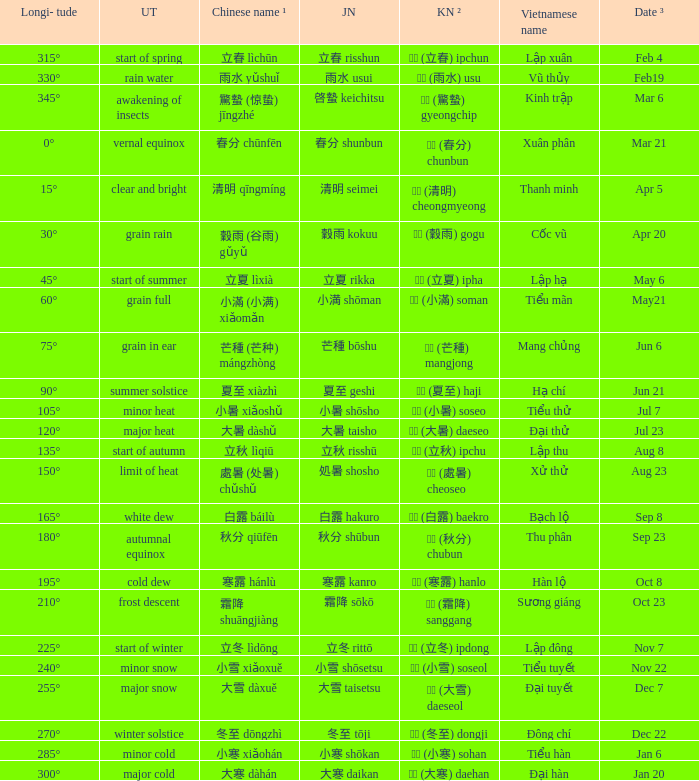Which Japanese name has a Korean name ² of 경칩 (驚蟄) gyeongchip? 啓蟄 keichitsu. 